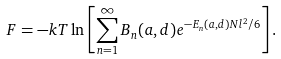<formula> <loc_0><loc_0><loc_500><loc_500>F = - k T \ln \left [ \sum _ { n = 1 } ^ { \infty } B _ { n } ( a , d ) e ^ { - E _ { n } ( a , d ) N l ^ { 2 } / 6 } \right ] .</formula> 